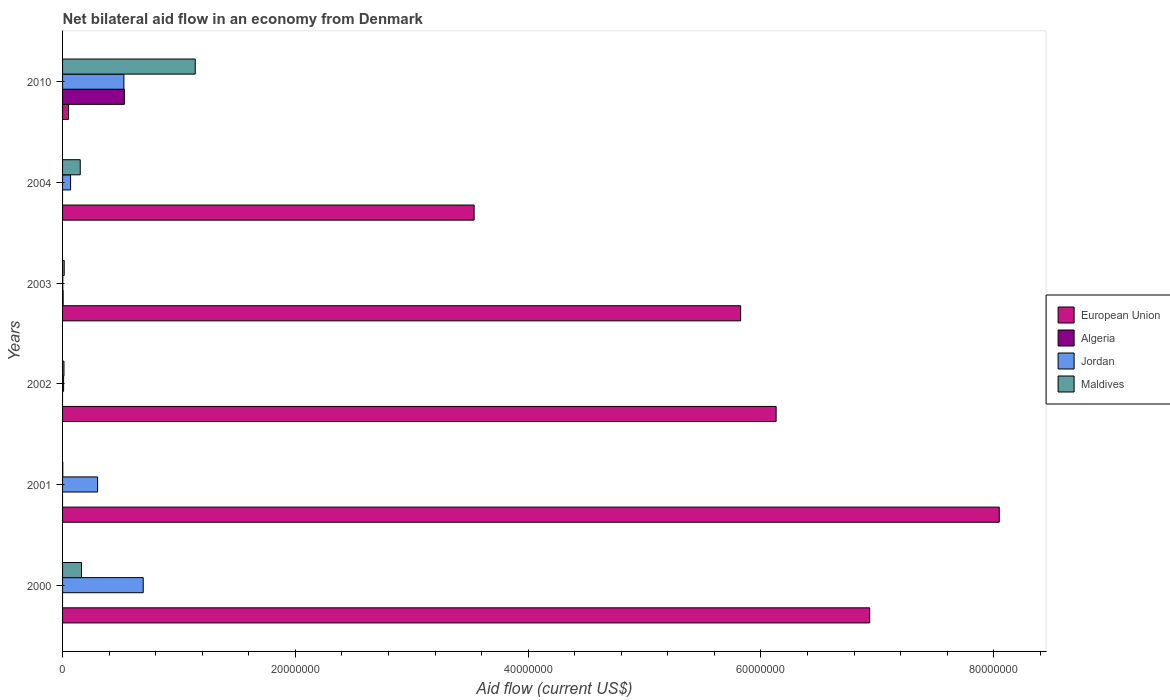How many groups of bars are there?
Your answer should be very brief. 6. Are the number of bars on each tick of the Y-axis equal?
Make the answer very short. No. How many bars are there on the 4th tick from the bottom?
Give a very brief answer. 4. In how many cases, is the number of bars for a given year not equal to the number of legend labels?
Offer a very short reply. 4. What is the net bilateral aid flow in Maldives in 2000?
Give a very brief answer. 1.63e+06. Across all years, what is the maximum net bilateral aid flow in Algeria?
Ensure brevity in your answer.  5.31e+06. Across all years, what is the minimum net bilateral aid flow in Algeria?
Offer a very short reply. 0. In which year was the net bilateral aid flow in Maldives maximum?
Keep it short and to the point. 2010. What is the total net bilateral aid flow in Algeria in the graph?
Ensure brevity in your answer.  5.36e+06. What is the difference between the net bilateral aid flow in Maldives in 2000 and that in 2010?
Offer a terse response. -9.77e+06. What is the difference between the net bilateral aid flow in Maldives in 2004 and the net bilateral aid flow in European Union in 2002?
Ensure brevity in your answer.  -5.98e+07. What is the average net bilateral aid flow in Algeria per year?
Ensure brevity in your answer.  8.93e+05. In the year 2000, what is the difference between the net bilateral aid flow in Jordan and net bilateral aid flow in Maldives?
Your answer should be compact. 5.30e+06. In how many years, is the net bilateral aid flow in European Union greater than 56000000 US$?
Offer a terse response. 4. What is the ratio of the net bilateral aid flow in Maldives in 2004 to that in 2010?
Offer a terse response. 0.13. Is the net bilateral aid flow in Jordan in 2000 less than that in 2004?
Offer a very short reply. No. What is the difference between the highest and the second highest net bilateral aid flow in Maldives?
Offer a very short reply. 9.77e+06. What is the difference between the highest and the lowest net bilateral aid flow in Maldives?
Offer a very short reply. 1.14e+07. Is it the case that in every year, the sum of the net bilateral aid flow in Jordan and net bilateral aid flow in Algeria is greater than the net bilateral aid flow in European Union?
Offer a terse response. No. Are the values on the major ticks of X-axis written in scientific E-notation?
Your response must be concise. No. Does the graph contain any zero values?
Your response must be concise. Yes. Does the graph contain grids?
Provide a succinct answer. No. How are the legend labels stacked?
Make the answer very short. Vertical. What is the title of the graph?
Offer a terse response. Net bilateral aid flow in an economy from Denmark. Does "Tuvalu" appear as one of the legend labels in the graph?
Provide a succinct answer. No. What is the label or title of the Y-axis?
Give a very brief answer. Years. What is the Aid flow (current US$) in European Union in 2000?
Offer a terse response. 6.94e+07. What is the Aid flow (current US$) in Jordan in 2000?
Your answer should be compact. 6.93e+06. What is the Aid flow (current US$) in Maldives in 2000?
Provide a short and direct response. 1.63e+06. What is the Aid flow (current US$) of European Union in 2001?
Your answer should be very brief. 8.05e+07. What is the Aid flow (current US$) in Algeria in 2001?
Offer a very short reply. 0. What is the Aid flow (current US$) in Jordan in 2001?
Offer a terse response. 3.01e+06. What is the Aid flow (current US$) in Maldives in 2001?
Offer a very short reply. 2.00e+04. What is the Aid flow (current US$) in European Union in 2002?
Keep it short and to the point. 6.13e+07. What is the Aid flow (current US$) in European Union in 2003?
Make the answer very short. 5.83e+07. What is the Aid flow (current US$) in Algeria in 2003?
Your answer should be very brief. 5.00e+04. What is the Aid flow (current US$) of Jordan in 2003?
Keep it short and to the point. 2.00e+04. What is the Aid flow (current US$) of European Union in 2004?
Your response must be concise. 3.54e+07. What is the Aid flow (current US$) in Jordan in 2004?
Offer a very short reply. 6.90e+05. What is the Aid flow (current US$) of Maldives in 2004?
Keep it short and to the point. 1.52e+06. What is the Aid flow (current US$) in European Union in 2010?
Offer a very short reply. 5.10e+05. What is the Aid flow (current US$) in Algeria in 2010?
Ensure brevity in your answer.  5.31e+06. What is the Aid flow (current US$) of Jordan in 2010?
Provide a short and direct response. 5.27e+06. What is the Aid flow (current US$) in Maldives in 2010?
Keep it short and to the point. 1.14e+07. Across all years, what is the maximum Aid flow (current US$) in European Union?
Give a very brief answer. 8.05e+07. Across all years, what is the maximum Aid flow (current US$) of Algeria?
Your answer should be very brief. 5.31e+06. Across all years, what is the maximum Aid flow (current US$) of Jordan?
Provide a short and direct response. 6.93e+06. Across all years, what is the maximum Aid flow (current US$) of Maldives?
Offer a terse response. 1.14e+07. Across all years, what is the minimum Aid flow (current US$) in European Union?
Keep it short and to the point. 5.10e+05. Across all years, what is the minimum Aid flow (current US$) in Maldives?
Give a very brief answer. 2.00e+04. What is the total Aid flow (current US$) in European Union in the graph?
Provide a short and direct response. 3.05e+08. What is the total Aid flow (current US$) in Algeria in the graph?
Your answer should be compact. 5.36e+06. What is the total Aid flow (current US$) in Jordan in the graph?
Your response must be concise. 1.60e+07. What is the total Aid flow (current US$) in Maldives in the graph?
Keep it short and to the point. 1.48e+07. What is the difference between the Aid flow (current US$) in European Union in 2000 and that in 2001?
Offer a very short reply. -1.11e+07. What is the difference between the Aid flow (current US$) of Jordan in 2000 and that in 2001?
Offer a terse response. 3.92e+06. What is the difference between the Aid flow (current US$) of Maldives in 2000 and that in 2001?
Your response must be concise. 1.61e+06. What is the difference between the Aid flow (current US$) of European Union in 2000 and that in 2002?
Provide a succinct answer. 8.04e+06. What is the difference between the Aid flow (current US$) in Jordan in 2000 and that in 2002?
Your answer should be very brief. 6.84e+06. What is the difference between the Aid flow (current US$) in Maldives in 2000 and that in 2002?
Your response must be concise. 1.51e+06. What is the difference between the Aid flow (current US$) in European Union in 2000 and that in 2003?
Your response must be concise. 1.11e+07. What is the difference between the Aid flow (current US$) in Jordan in 2000 and that in 2003?
Offer a very short reply. 6.91e+06. What is the difference between the Aid flow (current US$) of Maldives in 2000 and that in 2003?
Give a very brief answer. 1.49e+06. What is the difference between the Aid flow (current US$) in European Union in 2000 and that in 2004?
Keep it short and to the point. 3.40e+07. What is the difference between the Aid flow (current US$) of Jordan in 2000 and that in 2004?
Your response must be concise. 6.24e+06. What is the difference between the Aid flow (current US$) of European Union in 2000 and that in 2010?
Provide a short and direct response. 6.88e+07. What is the difference between the Aid flow (current US$) of Jordan in 2000 and that in 2010?
Give a very brief answer. 1.66e+06. What is the difference between the Aid flow (current US$) of Maldives in 2000 and that in 2010?
Make the answer very short. -9.77e+06. What is the difference between the Aid flow (current US$) of European Union in 2001 and that in 2002?
Offer a terse response. 1.92e+07. What is the difference between the Aid flow (current US$) in Jordan in 2001 and that in 2002?
Your answer should be compact. 2.92e+06. What is the difference between the Aid flow (current US$) in European Union in 2001 and that in 2003?
Provide a succinct answer. 2.22e+07. What is the difference between the Aid flow (current US$) of Jordan in 2001 and that in 2003?
Provide a succinct answer. 2.99e+06. What is the difference between the Aid flow (current US$) in European Union in 2001 and that in 2004?
Provide a succinct answer. 4.51e+07. What is the difference between the Aid flow (current US$) in Jordan in 2001 and that in 2004?
Offer a terse response. 2.32e+06. What is the difference between the Aid flow (current US$) in Maldives in 2001 and that in 2004?
Your answer should be very brief. -1.50e+06. What is the difference between the Aid flow (current US$) in European Union in 2001 and that in 2010?
Offer a very short reply. 8.00e+07. What is the difference between the Aid flow (current US$) in Jordan in 2001 and that in 2010?
Provide a short and direct response. -2.26e+06. What is the difference between the Aid flow (current US$) of Maldives in 2001 and that in 2010?
Make the answer very short. -1.14e+07. What is the difference between the Aid flow (current US$) in European Union in 2002 and that in 2003?
Offer a very short reply. 3.05e+06. What is the difference between the Aid flow (current US$) in Jordan in 2002 and that in 2003?
Ensure brevity in your answer.  7.00e+04. What is the difference between the Aid flow (current US$) in Maldives in 2002 and that in 2003?
Your answer should be compact. -2.00e+04. What is the difference between the Aid flow (current US$) in European Union in 2002 and that in 2004?
Provide a short and direct response. 2.60e+07. What is the difference between the Aid flow (current US$) of Jordan in 2002 and that in 2004?
Your answer should be very brief. -6.00e+05. What is the difference between the Aid flow (current US$) of Maldives in 2002 and that in 2004?
Keep it short and to the point. -1.40e+06. What is the difference between the Aid flow (current US$) in European Union in 2002 and that in 2010?
Your response must be concise. 6.08e+07. What is the difference between the Aid flow (current US$) in Jordan in 2002 and that in 2010?
Your response must be concise. -5.18e+06. What is the difference between the Aid flow (current US$) in Maldives in 2002 and that in 2010?
Offer a very short reply. -1.13e+07. What is the difference between the Aid flow (current US$) in European Union in 2003 and that in 2004?
Your response must be concise. 2.29e+07. What is the difference between the Aid flow (current US$) of Jordan in 2003 and that in 2004?
Provide a short and direct response. -6.70e+05. What is the difference between the Aid flow (current US$) of Maldives in 2003 and that in 2004?
Offer a very short reply. -1.38e+06. What is the difference between the Aid flow (current US$) in European Union in 2003 and that in 2010?
Your answer should be compact. 5.78e+07. What is the difference between the Aid flow (current US$) in Algeria in 2003 and that in 2010?
Your answer should be compact. -5.26e+06. What is the difference between the Aid flow (current US$) of Jordan in 2003 and that in 2010?
Provide a short and direct response. -5.25e+06. What is the difference between the Aid flow (current US$) in Maldives in 2003 and that in 2010?
Give a very brief answer. -1.13e+07. What is the difference between the Aid flow (current US$) of European Union in 2004 and that in 2010?
Ensure brevity in your answer.  3.48e+07. What is the difference between the Aid flow (current US$) of Jordan in 2004 and that in 2010?
Your answer should be compact. -4.58e+06. What is the difference between the Aid flow (current US$) in Maldives in 2004 and that in 2010?
Offer a very short reply. -9.88e+06. What is the difference between the Aid flow (current US$) in European Union in 2000 and the Aid flow (current US$) in Jordan in 2001?
Keep it short and to the point. 6.63e+07. What is the difference between the Aid flow (current US$) in European Union in 2000 and the Aid flow (current US$) in Maldives in 2001?
Make the answer very short. 6.93e+07. What is the difference between the Aid flow (current US$) of Jordan in 2000 and the Aid flow (current US$) of Maldives in 2001?
Make the answer very short. 6.91e+06. What is the difference between the Aid flow (current US$) of European Union in 2000 and the Aid flow (current US$) of Jordan in 2002?
Your answer should be very brief. 6.93e+07. What is the difference between the Aid flow (current US$) of European Union in 2000 and the Aid flow (current US$) of Maldives in 2002?
Make the answer very short. 6.92e+07. What is the difference between the Aid flow (current US$) of Jordan in 2000 and the Aid flow (current US$) of Maldives in 2002?
Provide a succinct answer. 6.81e+06. What is the difference between the Aid flow (current US$) of European Union in 2000 and the Aid flow (current US$) of Algeria in 2003?
Your answer should be compact. 6.93e+07. What is the difference between the Aid flow (current US$) of European Union in 2000 and the Aid flow (current US$) of Jordan in 2003?
Make the answer very short. 6.93e+07. What is the difference between the Aid flow (current US$) of European Union in 2000 and the Aid flow (current US$) of Maldives in 2003?
Offer a terse response. 6.92e+07. What is the difference between the Aid flow (current US$) in Jordan in 2000 and the Aid flow (current US$) in Maldives in 2003?
Offer a terse response. 6.79e+06. What is the difference between the Aid flow (current US$) in European Union in 2000 and the Aid flow (current US$) in Jordan in 2004?
Your answer should be compact. 6.87e+07. What is the difference between the Aid flow (current US$) in European Union in 2000 and the Aid flow (current US$) in Maldives in 2004?
Make the answer very short. 6.78e+07. What is the difference between the Aid flow (current US$) of Jordan in 2000 and the Aid flow (current US$) of Maldives in 2004?
Provide a short and direct response. 5.41e+06. What is the difference between the Aid flow (current US$) of European Union in 2000 and the Aid flow (current US$) of Algeria in 2010?
Provide a succinct answer. 6.40e+07. What is the difference between the Aid flow (current US$) of European Union in 2000 and the Aid flow (current US$) of Jordan in 2010?
Ensure brevity in your answer.  6.41e+07. What is the difference between the Aid flow (current US$) of European Union in 2000 and the Aid flow (current US$) of Maldives in 2010?
Your answer should be compact. 5.80e+07. What is the difference between the Aid flow (current US$) of Jordan in 2000 and the Aid flow (current US$) of Maldives in 2010?
Offer a terse response. -4.47e+06. What is the difference between the Aid flow (current US$) in European Union in 2001 and the Aid flow (current US$) in Jordan in 2002?
Offer a terse response. 8.04e+07. What is the difference between the Aid flow (current US$) of European Union in 2001 and the Aid flow (current US$) of Maldives in 2002?
Your answer should be compact. 8.04e+07. What is the difference between the Aid flow (current US$) in Jordan in 2001 and the Aid flow (current US$) in Maldives in 2002?
Your response must be concise. 2.89e+06. What is the difference between the Aid flow (current US$) in European Union in 2001 and the Aid flow (current US$) in Algeria in 2003?
Ensure brevity in your answer.  8.04e+07. What is the difference between the Aid flow (current US$) of European Union in 2001 and the Aid flow (current US$) of Jordan in 2003?
Ensure brevity in your answer.  8.05e+07. What is the difference between the Aid flow (current US$) in European Union in 2001 and the Aid flow (current US$) in Maldives in 2003?
Provide a succinct answer. 8.03e+07. What is the difference between the Aid flow (current US$) of Jordan in 2001 and the Aid flow (current US$) of Maldives in 2003?
Your answer should be very brief. 2.87e+06. What is the difference between the Aid flow (current US$) in European Union in 2001 and the Aid flow (current US$) in Jordan in 2004?
Provide a succinct answer. 7.98e+07. What is the difference between the Aid flow (current US$) in European Union in 2001 and the Aid flow (current US$) in Maldives in 2004?
Your answer should be compact. 7.90e+07. What is the difference between the Aid flow (current US$) of Jordan in 2001 and the Aid flow (current US$) of Maldives in 2004?
Your answer should be very brief. 1.49e+06. What is the difference between the Aid flow (current US$) in European Union in 2001 and the Aid flow (current US$) in Algeria in 2010?
Provide a succinct answer. 7.52e+07. What is the difference between the Aid flow (current US$) in European Union in 2001 and the Aid flow (current US$) in Jordan in 2010?
Ensure brevity in your answer.  7.52e+07. What is the difference between the Aid flow (current US$) in European Union in 2001 and the Aid flow (current US$) in Maldives in 2010?
Give a very brief answer. 6.91e+07. What is the difference between the Aid flow (current US$) in Jordan in 2001 and the Aid flow (current US$) in Maldives in 2010?
Your answer should be compact. -8.39e+06. What is the difference between the Aid flow (current US$) of European Union in 2002 and the Aid flow (current US$) of Algeria in 2003?
Ensure brevity in your answer.  6.13e+07. What is the difference between the Aid flow (current US$) of European Union in 2002 and the Aid flow (current US$) of Jordan in 2003?
Offer a very short reply. 6.13e+07. What is the difference between the Aid flow (current US$) of European Union in 2002 and the Aid flow (current US$) of Maldives in 2003?
Give a very brief answer. 6.12e+07. What is the difference between the Aid flow (current US$) of European Union in 2002 and the Aid flow (current US$) of Jordan in 2004?
Make the answer very short. 6.06e+07. What is the difference between the Aid flow (current US$) in European Union in 2002 and the Aid flow (current US$) in Maldives in 2004?
Keep it short and to the point. 5.98e+07. What is the difference between the Aid flow (current US$) in Jordan in 2002 and the Aid flow (current US$) in Maldives in 2004?
Your answer should be compact. -1.43e+06. What is the difference between the Aid flow (current US$) of European Union in 2002 and the Aid flow (current US$) of Algeria in 2010?
Your answer should be very brief. 5.60e+07. What is the difference between the Aid flow (current US$) of European Union in 2002 and the Aid flow (current US$) of Jordan in 2010?
Make the answer very short. 5.60e+07. What is the difference between the Aid flow (current US$) in European Union in 2002 and the Aid flow (current US$) in Maldives in 2010?
Your answer should be compact. 4.99e+07. What is the difference between the Aid flow (current US$) in Jordan in 2002 and the Aid flow (current US$) in Maldives in 2010?
Make the answer very short. -1.13e+07. What is the difference between the Aid flow (current US$) in European Union in 2003 and the Aid flow (current US$) in Jordan in 2004?
Your response must be concise. 5.76e+07. What is the difference between the Aid flow (current US$) of European Union in 2003 and the Aid flow (current US$) of Maldives in 2004?
Ensure brevity in your answer.  5.67e+07. What is the difference between the Aid flow (current US$) in Algeria in 2003 and the Aid flow (current US$) in Jordan in 2004?
Ensure brevity in your answer.  -6.40e+05. What is the difference between the Aid flow (current US$) of Algeria in 2003 and the Aid flow (current US$) of Maldives in 2004?
Your response must be concise. -1.47e+06. What is the difference between the Aid flow (current US$) in Jordan in 2003 and the Aid flow (current US$) in Maldives in 2004?
Give a very brief answer. -1.50e+06. What is the difference between the Aid flow (current US$) in European Union in 2003 and the Aid flow (current US$) in Algeria in 2010?
Your answer should be very brief. 5.30e+07. What is the difference between the Aid flow (current US$) of European Union in 2003 and the Aid flow (current US$) of Jordan in 2010?
Provide a succinct answer. 5.30e+07. What is the difference between the Aid flow (current US$) in European Union in 2003 and the Aid flow (current US$) in Maldives in 2010?
Keep it short and to the point. 4.69e+07. What is the difference between the Aid flow (current US$) in Algeria in 2003 and the Aid flow (current US$) in Jordan in 2010?
Offer a very short reply. -5.22e+06. What is the difference between the Aid flow (current US$) of Algeria in 2003 and the Aid flow (current US$) of Maldives in 2010?
Provide a short and direct response. -1.14e+07. What is the difference between the Aid flow (current US$) in Jordan in 2003 and the Aid flow (current US$) in Maldives in 2010?
Make the answer very short. -1.14e+07. What is the difference between the Aid flow (current US$) of European Union in 2004 and the Aid flow (current US$) of Algeria in 2010?
Offer a terse response. 3.00e+07. What is the difference between the Aid flow (current US$) in European Union in 2004 and the Aid flow (current US$) in Jordan in 2010?
Ensure brevity in your answer.  3.01e+07. What is the difference between the Aid flow (current US$) of European Union in 2004 and the Aid flow (current US$) of Maldives in 2010?
Provide a short and direct response. 2.40e+07. What is the difference between the Aid flow (current US$) in Jordan in 2004 and the Aid flow (current US$) in Maldives in 2010?
Give a very brief answer. -1.07e+07. What is the average Aid flow (current US$) in European Union per year?
Make the answer very short. 5.09e+07. What is the average Aid flow (current US$) of Algeria per year?
Your response must be concise. 8.93e+05. What is the average Aid flow (current US$) of Jordan per year?
Provide a succinct answer. 2.67e+06. What is the average Aid flow (current US$) in Maldives per year?
Your answer should be compact. 2.47e+06. In the year 2000, what is the difference between the Aid flow (current US$) of European Union and Aid flow (current US$) of Jordan?
Offer a very short reply. 6.24e+07. In the year 2000, what is the difference between the Aid flow (current US$) of European Union and Aid flow (current US$) of Maldives?
Give a very brief answer. 6.77e+07. In the year 2000, what is the difference between the Aid flow (current US$) of Jordan and Aid flow (current US$) of Maldives?
Your response must be concise. 5.30e+06. In the year 2001, what is the difference between the Aid flow (current US$) in European Union and Aid flow (current US$) in Jordan?
Keep it short and to the point. 7.75e+07. In the year 2001, what is the difference between the Aid flow (current US$) in European Union and Aid flow (current US$) in Maldives?
Provide a succinct answer. 8.05e+07. In the year 2001, what is the difference between the Aid flow (current US$) of Jordan and Aid flow (current US$) of Maldives?
Provide a short and direct response. 2.99e+06. In the year 2002, what is the difference between the Aid flow (current US$) of European Union and Aid flow (current US$) of Jordan?
Make the answer very short. 6.12e+07. In the year 2002, what is the difference between the Aid flow (current US$) of European Union and Aid flow (current US$) of Maldives?
Provide a short and direct response. 6.12e+07. In the year 2002, what is the difference between the Aid flow (current US$) in Jordan and Aid flow (current US$) in Maldives?
Provide a succinct answer. -3.00e+04. In the year 2003, what is the difference between the Aid flow (current US$) of European Union and Aid flow (current US$) of Algeria?
Provide a succinct answer. 5.82e+07. In the year 2003, what is the difference between the Aid flow (current US$) of European Union and Aid flow (current US$) of Jordan?
Ensure brevity in your answer.  5.82e+07. In the year 2003, what is the difference between the Aid flow (current US$) in European Union and Aid flow (current US$) in Maldives?
Offer a terse response. 5.81e+07. In the year 2004, what is the difference between the Aid flow (current US$) in European Union and Aid flow (current US$) in Jordan?
Provide a succinct answer. 3.47e+07. In the year 2004, what is the difference between the Aid flow (current US$) of European Union and Aid flow (current US$) of Maldives?
Keep it short and to the point. 3.38e+07. In the year 2004, what is the difference between the Aid flow (current US$) of Jordan and Aid flow (current US$) of Maldives?
Your response must be concise. -8.30e+05. In the year 2010, what is the difference between the Aid flow (current US$) in European Union and Aid flow (current US$) in Algeria?
Ensure brevity in your answer.  -4.80e+06. In the year 2010, what is the difference between the Aid flow (current US$) of European Union and Aid flow (current US$) of Jordan?
Provide a succinct answer. -4.76e+06. In the year 2010, what is the difference between the Aid flow (current US$) of European Union and Aid flow (current US$) of Maldives?
Offer a terse response. -1.09e+07. In the year 2010, what is the difference between the Aid flow (current US$) in Algeria and Aid flow (current US$) in Maldives?
Your response must be concise. -6.09e+06. In the year 2010, what is the difference between the Aid flow (current US$) of Jordan and Aid flow (current US$) of Maldives?
Provide a short and direct response. -6.13e+06. What is the ratio of the Aid flow (current US$) in European Union in 2000 to that in 2001?
Provide a succinct answer. 0.86. What is the ratio of the Aid flow (current US$) in Jordan in 2000 to that in 2001?
Your answer should be compact. 2.3. What is the ratio of the Aid flow (current US$) of Maldives in 2000 to that in 2001?
Your answer should be very brief. 81.5. What is the ratio of the Aid flow (current US$) in European Union in 2000 to that in 2002?
Provide a succinct answer. 1.13. What is the ratio of the Aid flow (current US$) in Maldives in 2000 to that in 2002?
Make the answer very short. 13.58. What is the ratio of the Aid flow (current US$) in European Union in 2000 to that in 2003?
Provide a succinct answer. 1.19. What is the ratio of the Aid flow (current US$) in Jordan in 2000 to that in 2003?
Give a very brief answer. 346.5. What is the ratio of the Aid flow (current US$) in Maldives in 2000 to that in 2003?
Ensure brevity in your answer.  11.64. What is the ratio of the Aid flow (current US$) in European Union in 2000 to that in 2004?
Make the answer very short. 1.96. What is the ratio of the Aid flow (current US$) of Jordan in 2000 to that in 2004?
Provide a succinct answer. 10.04. What is the ratio of the Aid flow (current US$) in Maldives in 2000 to that in 2004?
Give a very brief answer. 1.07. What is the ratio of the Aid flow (current US$) in European Union in 2000 to that in 2010?
Offer a very short reply. 135.98. What is the ratio of the Aid flow (current US$) in Jordan in 2000 to that in 2010?
Offer a very short reply. 1.31. What is the ratio of the Aid flow (current US$) in Maldives in 2000 to that in 2010?
Keep it short and to the point. 0.14. What is the ratio of the Aid flow (current US$) in European Union in 2001 to that in 2002?
Offer a terse response. 1.31. What is the ratio of the Aid flow (current US$) of Jordan in 2001 to that in 2002?
Ensure brevity in your answer.  33.44. What is the ratio of the Aid flow (current US$) in European Union in 2001 to that in 2003?
Make the answer very short. 1.38. What is the ratio of the Aid flow (current US$) in Jordan in 2001 to that in 2003?
Your answer should be compact. 150.5. What is the ratio of the Aid flow (current US$) in Maldives in 2001 to that in 2003?
Give a very brief answer. 0.14. What is the ratio of the Aid flow (current US$) in European Union in 2001 to that in 2004?
Provide a succinct answer. 2.28. What is the ratio of the Aid flow (current US$) in Jordan in 2001 to that in 2004?
Provide a short and direct response. 4.36. What is the ratio of the Aid flow (current US$) in Maldives in 2001 to that in 2004?
Give a very brief answer. 0.01. What is the ratio of the Aid flow (current US$) of European Union in 2001 to that in 2010?
Offer a terse response. 157.8. What is the ratio of the Aid flow (current US$) of Jordan in 2001 to that in 2010?
Keep it short and to the point. 0.57. What is the ratio of the Aid flow (current US$) in Maldives in 2001 to that in 2010?
Make the answer very short. 0. What is the ratio of the Aid flow (current US$) of European Union in 2002 to that in 2003?
Make the answer very short. 1.05. What is the ratio of the Aid flow (current US$) of Maldives in 2002 to that in 2003?
Your response must be concise. 0.86. What is the ratio of the Aid flow (current US$) of European Union in 2002 to that in 2004?
Give a very brief answer. 1.73. What is the ratio of the Aid flow (current US$) in Jordan in 2002 to that in 2004?
Ensure brevity in your answer.  0.13. What is the ratio of the Aid flow (current US$) in Maldives in 2002 to that in 2004?
Provide a short and direct response. 0.08. What is the ratio of the Aid flow (current US$) of European Union in 2002 to that in 2010?
Make the answer very short. 120.22. What is the ratio of the Aid flow (current US$) in Jordan in 2002 to that in 2010?
Offer a terse response. 0.02. What is the ratio of the Aid flow (current US$) of Maldives in 2002 to that in 2010?
Provide a succinct answer. 0.01. What is the ratio of the Aid flow (current US$) of European Union in 2003 to that in 2004?
Your response must be concise. 1.65. What is the ratio of the Aid flow (current US$) in Jordan in 2003 to that in 2004?
Make the answer very short. 0.03. What is the ratio of the Aid flow (current US$) in Maldives in 2003 to that in 2004?
Your answer should be compact. 0.09. What is the ratio of the Aid flow (current US$) in European Union in 2003 to that in 2010?
Provide a succinct answer. 114.24. What is the ratio of the Aid flow (current US$) in Algeria in 2003 to that in 2010?
Keep it short and to the point. 0.01. What is the ratio of the Aid flow (current US$) in Jordan in 2003 to that in 2010?
Your answer should be very brief. 0. What is the ratio of the Aid flow (current US$) in Maldives in 2003 to that in 2010?
Provide a short and direct response. 0.01. What is the ratio of the Aid flow (current US$) of European Union in 2004 to that in 2010?
Your response must be concise. 69.33. What is the ratio of the Aid flow (current US$) in Jordan in 2004 to that in 2010?
Your answer should be compact. 0.13. What is the ratio of the Aid flow (current US$) in Maldives in 2004 to that in 2010?
Offer a terse response. 0.13. What is the difference between the highest and the second highest Aid flow (current US$) of European Union?
Your response must be concise. 1.11e+07. What is the difference between the highest and the second highest Aid flow (current US$) of Jordan?
Ensure brevity in your answer.  1.66e+06. What is the difference between the highest and the second highest Aid flow (current US$) in Maldives?
Ensure brevity in your answer.  9.77e+06. What is the difference between the highest and the lowest Aid flow (current US$) in European Union?
Give a very brief answer. 8.00e+07. What is the difference between the highest and the lowest Aid flow (current US$) in Algeria?
Offer a terse response. 5.31e+06. What is the difference between the highest and the lowest Aid flow (current US$) in Jordan?
Keep it short and to the point. 6.91e+06. What is the difference between the highest and the lowest Aid flow (current US$) of Maldives?
Offer a very short reply. 1.14e+07. 